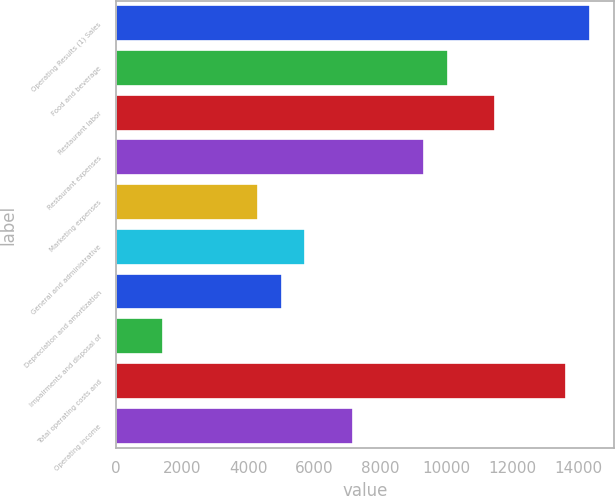Convert chart. <chart><loc_0><loc_0><loc_500><loc_500><bar_chart><fcel>Operating Results (1) Sales<fcel>Food and beverage<fcel>Restaurant labor<fcel>Restaurant expenses<fcel>Marketing expenses<fcel>General and administrative<fcel>Depreciation and amortization<fcel>Impairments and disposal of<fcel>Total operating costs and<fcel>Operating income<nl><fcel>14340.4<fcel>10038.3<fcel>11472.4<fcel>9321.29<fcel>4302.15<fcel>5736.19<fcel>5019.17<fcel>1434.07<fcel>13623.4<fcel>7170.23<nl></chart> 